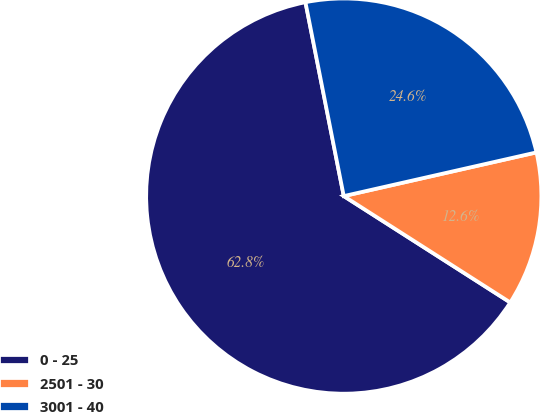Convert chart to OTSL. <chart><loc_0><loc_0><loc_500><loc_500><pie_chart><fcel>0 - 25<fcel>2501 - 30<fcel>3001 - 40<nl><fcel>62.85%<fcel>12.6%<fcel>24.56%<nl></chart> 